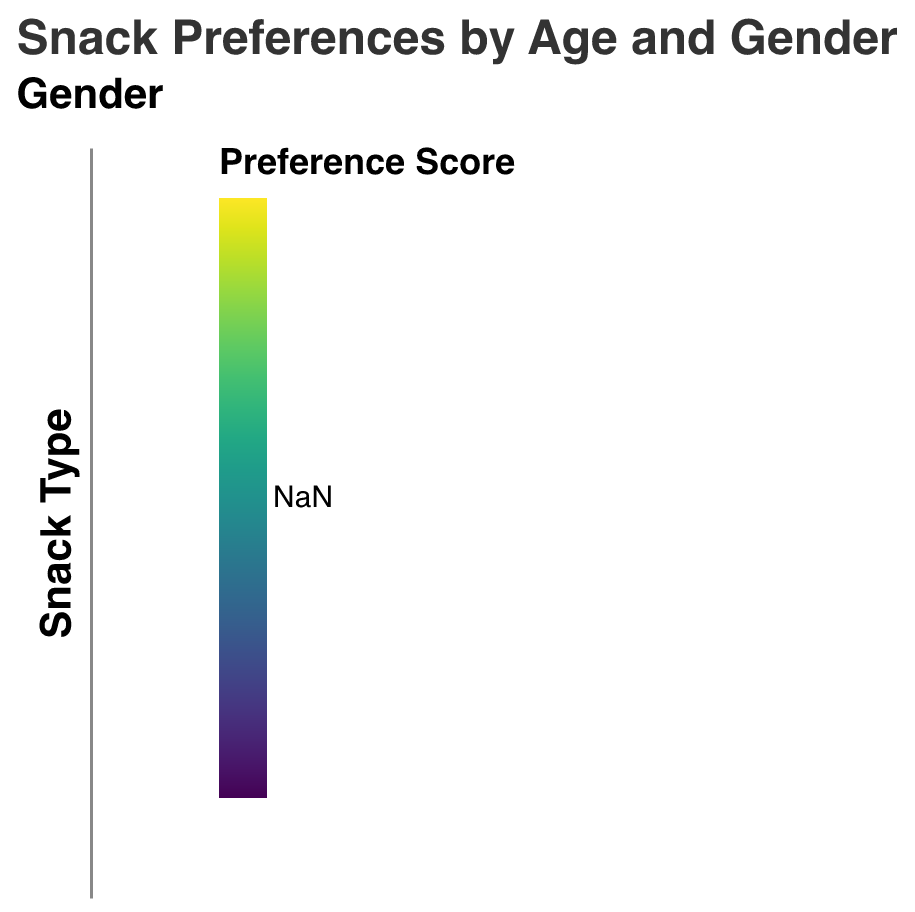What's the title of the figure? The title of the figure is "Snack Preferences by Age and Gender," which is clearly indicated at the top of the heatmap with bold and larger font size.
Answer: Snack Preferences by Age and Gender Which snack has the highest preference score among 25-34-year-old males? By observing the heatmap section for 25-34-year-old males, the darkest color, which indicates the highest preference score, appears next to "Chocolate" with a score of 18.
Answer: Chocolate What is the average preference score for vegetables for all age groups and genders? To calculate the average, sum the preference scores for vegetables across all age groups and genders: (3+4+4+5+6+8+9+10+10+11) = 70. Divide by the number of groups (10), resulting in an average score of 7.
Answer: 7 Which gender has a higher overall preference score for candy in the 18-24 age group? Comparing the heatmap cells for candy in the 18-24 age group, females have a preference score of 14 while males have a score of 12. Females have the higher preference score.
Answer: Female What is the combined preference score for cookies and granola bars among 35-44-year-old females? Add the preference scores for cookies and granola bars for 35-44-year-old females: Cookies (11) + Granola Bars (12) = 23.
Answer: 23 Is there any snack type that shows an increase in preference score with age for females? Analyzing each snack type for females across increasing age groups, "Vegetables" show an increasing trend: 4 (18-24) -> 5 (25-34) -> 8 (35-44) -> 10 (45-54) -> 11 (55-64).
Answer: Vegetables How does the preference score for fruit compare between 45-54-year-old males and females? The preference score for fruit among 45-54-year-old males is 10, while for females, it is 12. Females have a higher preference score for fruit.
Answer: Females have a higher preference Which age group has the highest preference score for chips among all genders? By examining the heatmap for the snack type "Chips," the darkest cell appears in the 35-44 age group for males with a score of 13, indicating the highest preference.
Answer: 35-44-year-old males What is the total preference score for chocolate for both genders in the 18-24 age group? Sum the preference scores for chocolate for males and females in the 18-24 age group: 15 (Male) + 13 (Female) = 28.
Answer: 28 In which age group do males and females have the least difference in their candy preference score? Calculate the preference score difference for candy between males and females across age groups. The smallest difference is observed in the 45-54 age group: 9 (Female) - 8 (Male) = 1.
Answer: 45-54 